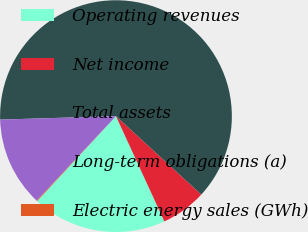Convert chart. <chart><loc_0><loc_0><loc_500><loc_500><pie_chart><fcel>Operating revenues<fcel>Net income<fcel>Total assets<fcel>Long-term obligations (a)<fcel>Electric energy sales (GWh)<nl><fcel>18.76%<fcel>6.31%<fcel>62.32%<fcel>12.53%<fcel>0.09%<nl></chart> 